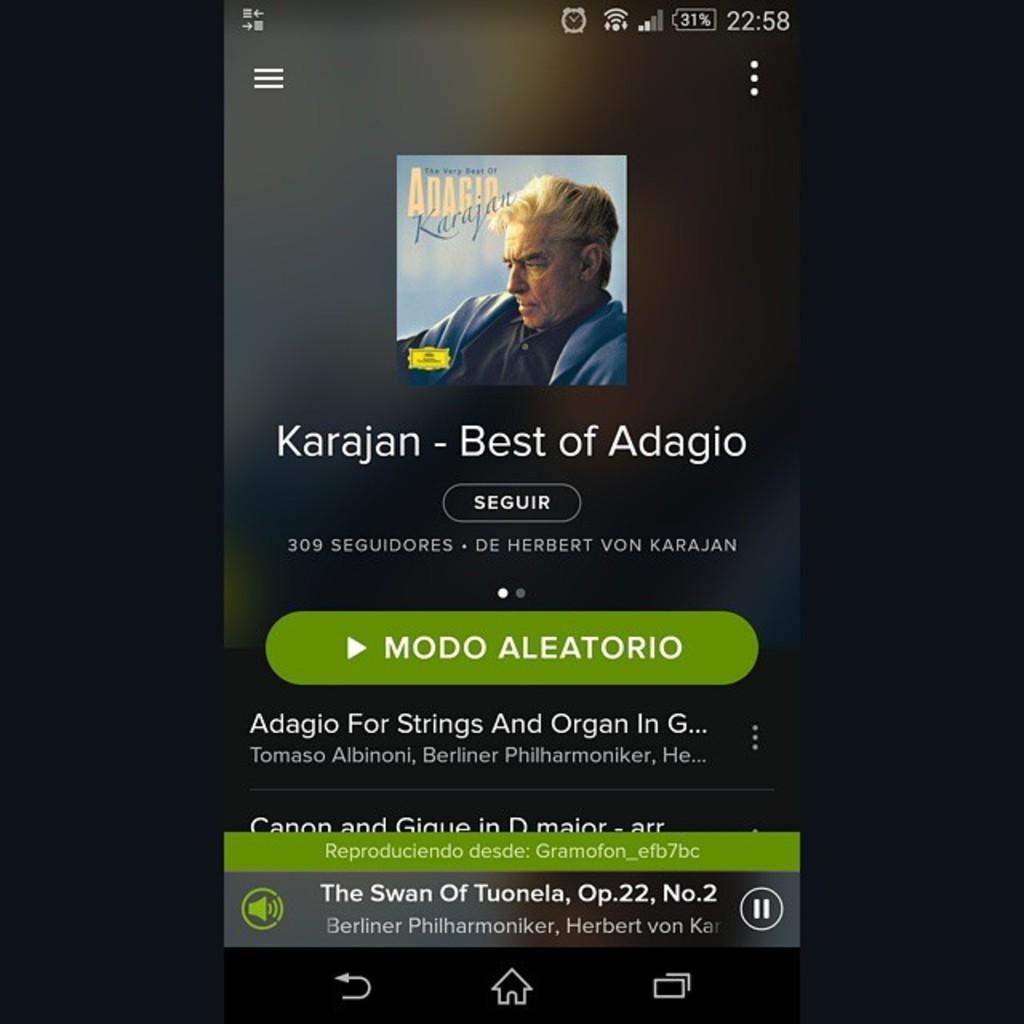Who is the artist of this album?
Your response must be concise. Karajan. What is the title of the album?
Ensure brevity in your answer.  Best of adagio. 